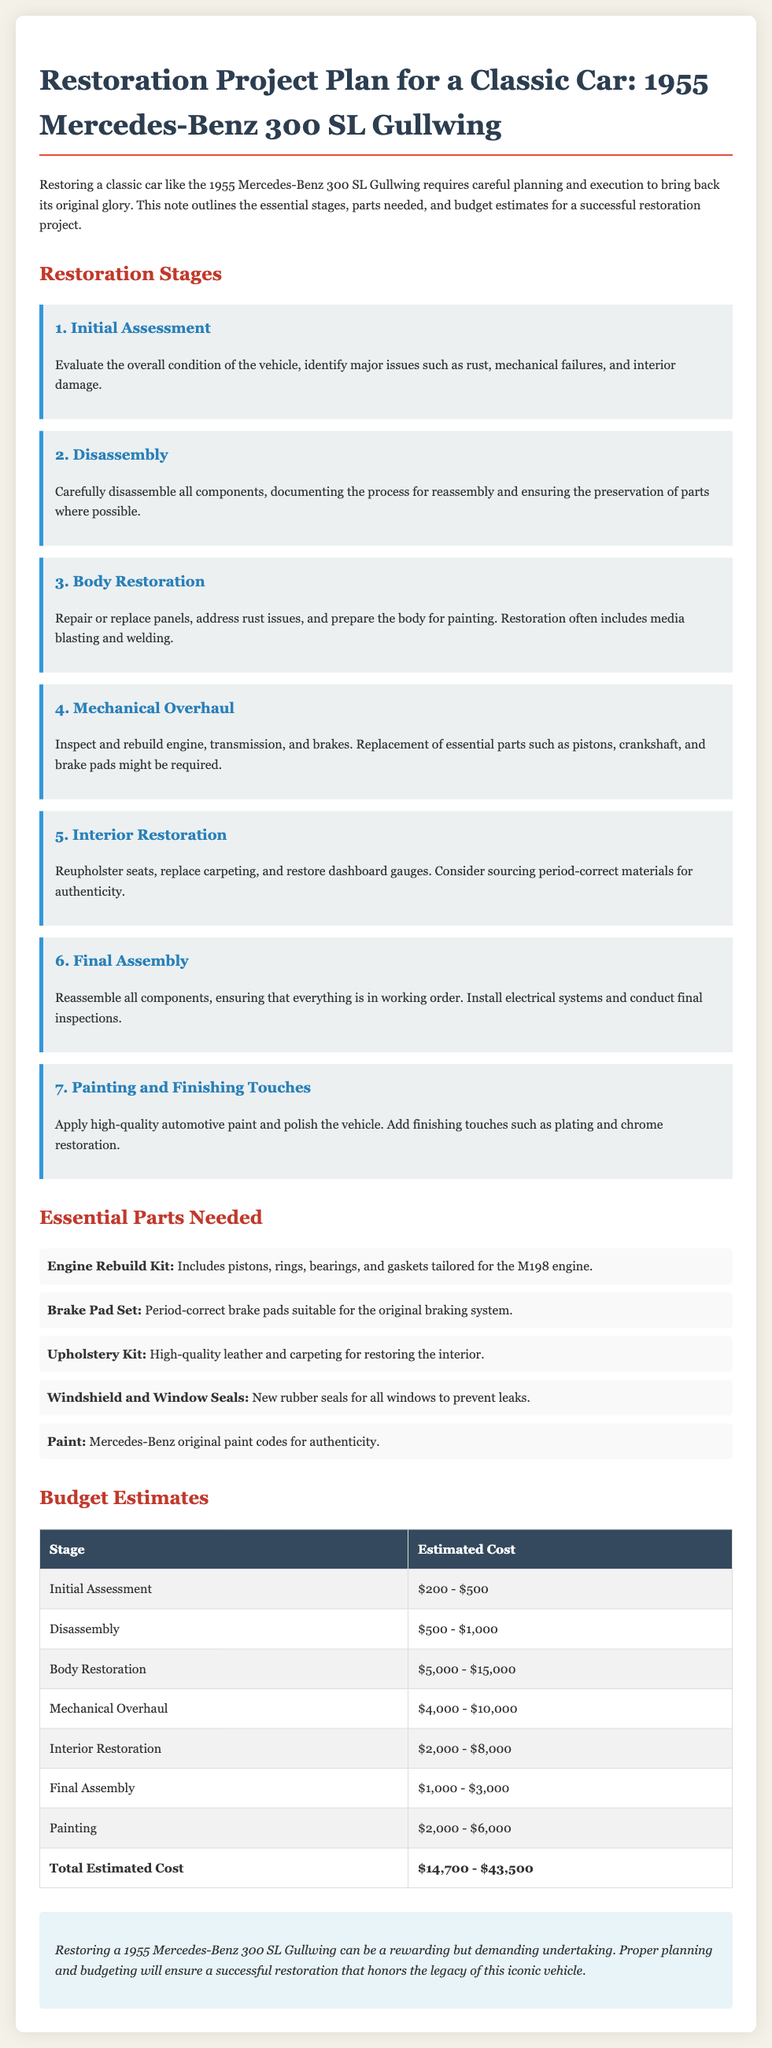What is the first stage of the restoration? The first stage is "Initial Assessment," which involves evaluating the overall condition of the vehicle.
Answer: Initial Assessment How much is estimated for the Body Restoration stage? The estimated cost for Body Restoration ranges from $5,000 to $15,000 according to the budget table.
Answer: $5,000 - $15,000 What part is needed for the engine? The document mentions an "Engine Rebuild Kit," tailored for the M198 engine.
Answer: Engine Rebuild Kit What is the total estimated cost range for the restoration? The total estimated cost is provided at the bottom of the budget table, summing up the individual stage estimates.
Answer: $14,700 - $43,500 Which stage includes interior work? The stage focused on interior work is "Interior Restoration," involving reupholstering seats and replacing carpeting.
Answer: Interior Restoration What is one of the key materials listed for interior restoration? The document specifies a "Upholstery Kit" that includes high-quality leather and carpeting.
Answer: Upholstery Kit What final step involves paint application? The last stage dedicated to paint application and detailing is "Painting and Finishing Touches."
Answer: Painting and Finishing Touches How many stages are listed in the restoration plan? There are 7 distinct stages outlined in the restoration plan for the classic car.
Answer: 7 